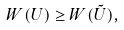Convert formula to latex. <formula><loc_0><loc_0><loc_500><loc_500>W ( U ) \geq W ( \tilde { U } ) ,</formula> 